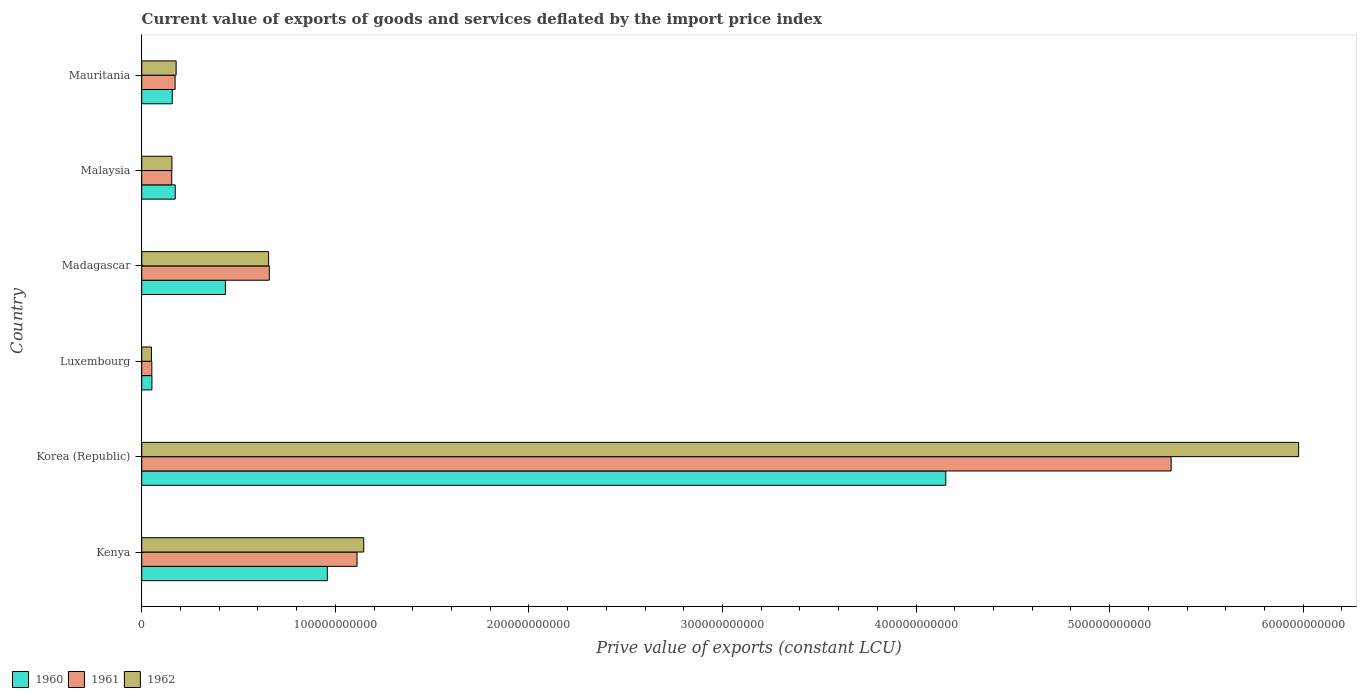How many groups of bars are there?
Offer a very short reply. 6. What is the label of the 6th group of bars from the top?
Offer a very short reply. Kenya. What is the prive value of exports in 1961 in Korea (Republic)?
Your answer should be compact. 5.32e+11. Across all countries, what is the maximum prive value of exports in 1960?
Offer a terse response. 4.15e+11. Across all countries, what is the minimum prive value of exports in 1960?
Your response must be concise. 5.28e+09. In which country was the prive value of exports in 1962 maximum?
Your response must be concise. Korea (Republic). In which country was the prive value of exports in 1960 minimum?
Keep it short and to the point. Luxembourg. What is the total prive value of exports in 1962 in the graph?
Provide a succinct answer. 8.16e+11. What is the difference between the prive value of exports in 1961 in Korea (Republic) and that in Mauritania?
Provide a succinct answer. 5.15e+11. What is the difference between the prive value of exports in 1962 in Luxembourg and the prive value of exports in 1961 in Madagascar?
Make the answer very short. -6.09e+1. What is the average prive value of exports in 1962 per country?
Ensure brevity in your answer.  1.36e+11. What is the difference between the prive value of exports in 1962 and prive value of exports in 1960 in Malaysia?
Your answer should be very brief. -1.70e+09. What is the ratio of the prive value of exports in 1961 in Kenya to that in Madagascar?
Provide a short and direct response. 1.69. Is the prive value of exports in 1960 in Kenya less than that in Madagascar?
Offer a very short reply. No. What is the difference between the highest and the second highest prive value of exports in 1960?
Provide a succinct answer. 3.19e+11. What is the difference between the highest and the lowest prive value of exports in 1962?
Ensure brevity in your answer.  5.93e+11. In how many countries, is the prive value of exports in 1962 greater than the average prive value of exports in 1962 taken over all countries?
Your answer should be very brief. 1. Is the sum of the prive value of exports in 1960 in Kenya and Korea (Republic) greater than the maximum prive value of exports in 1962 across all countries?
Make the answer very short. No. What does the 1st bar from the bottom in Mauritania represents?
Provide a succinct answer. 1960. Are all the bars in the graph horizontal?
Provide a succinct answer. Yes. What is the difference between two consecutive major ticks on the X-axis?
Your answer should be very brief. 1.00e+11. Are the values on the major ticks of X-axis written in scientific E-notation?
Offer a terse response. No. Does the graph contain any zero values?
Keep it short and to the point. No. How are the legend labels stacked?
Make the answer very short. Horizontal. What is the title of the graph?
Your response must be concise. Current value of exports of goods and services deflated by the import price index. Does "1995" appear as one of the legend labels in the graph?
Keep it short and to the point. No. What is the label or title of the X-axis?
Your answer should be very brief. Prive value of exports (constant LCU). What is the label or title of the Y-axis?
Provide a short and direct response. Country. What is the Prive value of exports (constant LCU) of 1960 in Kenya?
Your answer should be very brief. 9.59e+1. What is the Prive value of exports (constant LCU) of 1961 in Kenya?
Provide a succinct answer. 1.11e+11. What is the Prive value of exports (constant LCU) of 1962 in Kenya?
Offer a very short reply. 1.15e+11. What is the Prive value of exports (constant LCU) in 1960 in Korea (Republic)?
Offer a very short reply. 4.15e+11. What is the Prive value of exports (constant LCU) of 1961 in Korea (Republic)?
Your response must be concise. 5.32e+11. What is the Prive value of exports (constant LCU) of 1962 in Korea (Republic)?
Give a very brief answer. 5.98e+11. What is the Prive value of exports (constant LCU) of 1960 in Luxembourg?
Your answer should be very brief. 5.28e+09. What is the Prive value of exports (constant LCU) of 1961 in Luxembourg?
Your response must be concise. 5.22e+09. What is the Prive value of exports (constant LCU) in 1962 in Luxembourg?
Your response must be concise. 5.02e+09. What is the Prive value of exports (constant LCU) of 1960 in Madagascar?
Keep it short and to the point. 4.32e+1. What is the Prive value of exports (constant LCU) of 1961 in Madagascar?
Give a very brief answer. 6.59e+1. What is the Prive value of exports (constant LCU) of 1962 in Madagascar?
Offer a very short reply. 6.55e+1. What is the Prive value of exports (constant LCU) of 1960 in Malaysia?
Ensure brevity in your answer.  1.73e+1. What is the Prive value of exports (constant LCU) in 1961 in Malaysia?
Your answer should be very brief. 1.55e+1. What is the Prive value of exports (constant LCU) in 1962 in Malaysia?
Make the answer very short. 1.56e+1. What is the Prive value of exports (constant LCU) of 1960 in Mauritania?
Make the answer very short. 1.58e+1. What is the Prive value of exports (constant LCU) of 1961 in Mauritania?
Offer a very short reply. 1.72e+1. What is the Prive value of exports (constant LCU) in 1962 in Mauritania?
Give a very brief answer. 1.78e+1. Across all countries, what is the maximum Prive value of exports (constant LCU) of 1960?
Your response must be concise. 4.15e+11. Across all countries, what is the maximum Prive value of exports (constant LCU) of 1961?
Your response must be concise. 5.32e+11. Across all countries, what is the maximum Prive value of exports (constant LCU) in 1962?
Your answer should be compact. 5.98e+11. Across all countries, what is the minimum Prive value of exports (constant LCU) of 1960?
Give a very brief answer. 5.28e+09. Across all countries, what is the minimum Prive value of exports (constant LCU) of 1961?
Provide a short and direct response. 5.22e+09. Across all countries, what is the minimum Prive value of exports (constant LCU) of 1962?
Ensure brevity in your answer.  5.02e+09. What is the total Prive value of exports (constant LCU) of 1960 in the graph?
Offer a terse response. 5.93e+11. What is the total Prive value of exports (constant LCU) in 1961 in the graph?
Make the answer very short. 7.47e+11. What is the total Prive value of exports (constant LCU) of 1962 in the graph?
Your answer should be very brief. 8.16e+11. What is the difference between the Prive value of exports (constant LCU) in 1960 in Kenya and that in Korea (Republic)?
Give a very brief answer. -3.19e+11. What is the difference between the Prive value of exports (constant LCU) in 1961 in Kenya and that in Korea (Republic)?
Provide a succinct answer. -4.21e+11. What is the difference between the Prive value of exports (constant LCU) in 1962 in Kenya and that in Korea (Republic)?
Provide a succinct answer. -4.83e+11. What is the difference between the Prive value of exports (constant LCU) in 1960 in Kenya and that in Luxembourg?
Make the answer very short. 9.06e+1. What is the difference between the Prive value of exports (constant LCU) of 1961 in Kenya and that in Luxembourg?
Offer a terse response. 1.06e+11. What is the difference between the Prive value of exports (constant LCU) in 1962 in Kenya and that in Luxembourg?
Your answer should be very brief. 1.10e+11. What is the difference between the Prive value of exports (constant LCU) of 1960 in Kenya and that in Madagascar?
Provide a short and direct response. 5.27e+1. What is the difference between the Prive value of exports (constant LCU) in 1961 in Kenya and that in Madagascar?
Give a very brief answer. 4.53e+1. What is the difference between the Prive value of exports (constant LCU) of 1962 in Kenya and that in Madagascar?
Make the answer very short. 4.92e+1. What is the difference between the Prive value of exports (constant LCU) of 1960 in Kenya and that in Malaysia?
Offer a very short reply. 7.86e+1. What is the difference between the Prive value of exports (constant LCU) in 1961 in Kenya and that in Malaysia?
Your answer should be very brief. 9.57e+1. What is the difference between the Prive value of exports (constant LCU) in 1962 in Kenya and that in Malaysia?
Ensure brevity in your answer.  9.91e+1. What is the difference between the Prive value of exports (constant LCU) in 1960 in Kenya and that in Mauritania?
Keep it short and to the point. 8.01e+1. What is the difference between the Prive value of exports (constant LCU) in 1961 in Kenya and that in Mauritania?
Your answer should be very brief. 9.40e+1. What is the difference between the Prive value of exports (constant LCU) in 1962 in Kenya and that in Mauritania?
Give a very brief answer. 9.69e+1. What is the difference between the Prive value of exports (constant LCU) of 1960 in Korea (Republic) and that in Luxembourg?
Offer a terse response. 4.10e+11. What is the difference between the Prive value of exports (constant LCU) of 1961 in Korea (Republic) and that in Luxembourg?
Your response must be concise. 5.27e+11. What is the difference between the Prive value of exports (constant LCU) in 1962 in Korea (Republic) and that in Luxembourg?
Keep it short and to the point. 5.93e+11. What is the difference between the Prive value of exports (constant LCU) of 1960 in Korea (Republic) and that in Madagascar?
Provide a short and direct response. 3.72e+11. What is the difference between the Prive value of exports (constant LCU) in 1961 in Korea (Republic) and that in Madagascar?
Your answer should be very brief. 4.66e+11. What is the difference between the Prive value of exports (constant LCU) in 1962 in Korea (Republic) and that in Madagascar?
Your answer should be compact. 5.32e+11. What is the difference between the Prive value of exports (constant LCU) of 1960 in Korea (Republic) and that in Malaysia?
Your answer should be very brief. 3.98e+11. What is the difference between the Prive value of exports (constant LCU) of 1961 in Korea (Republic) and that in Malaysia?
Your response must be concise. 5.16e+11. What is the difference between the Prive value of exports (constant LCU) of 1962 in Korea (Republic) and that in Malaysia?
Your response must be concise. 5.82e+11. What is the difference between the Prive value of exports (constant LCU) in 1960 in Korea (Republic) and that in Mauritania?
Ensure brevity in your answer.  4.00e+11. What is the difference between the Prive value of exports (constant LCU) of 1961 in Korea (Republic) and that in Mauritania?
Keep it short and to the point. 5.15e+11. What is the difference between the Prive value of exports (constant LCU) in 1962 in Korea (Republic) and that in Mauritania?
Offer a terse response. 5.80e+11. What is the difference between the Prive value of exports (constant LCU) in 1960 in Luxembourg and that in Madagascar?
Your answer should be compact. -3.79e+1. What is the difference between the Prive value of exports (constant LCU) of 1961 in Luxembourg and that in Madagascar?
Provide a short and direct response. -6.07e+1. What is the difference between the Prive value of exports (constant LCU) of 1962 in Luxembourg and that in Madagascar?
Ensure brevity in your answer.  -6.05e+1. What is the difference between the Prive value of exports (constant LCU) in 1960 in Luxembourg and that in Malaysia?
Provide a succinct answer. -1.20e+1. What is the difference between the Prive value of exports (constant LCU) in 1961 in Luxembourg and that in Malaysia?
Offer a very short reply. -1.03e+1. What is the difference between the Prive value of exports (constant LCU) of 1962 in Luxembourg and that in Malaysia?
Ensure brevity in your answer.  -1.06e+1. What is the difference between the Prive value of exports (constant LCU) in 1960 in Luxembourg and that in Mauritania?
Your answer should be very brief. -1.05e+1. What is the difference between the Prive value of exports (constant LCU) of 1961 in Luxembourg and that in Mauritania?
Your answer should be compact. -1.20e+1. What is the difference between the Prive value of exports (constant LCU) of 1962 in Luxembourg and that in Mauritania?
Keep it short and to the point. -1.28e+1. What is the difference between the Prive value of exports (constant LCU) in 1960 in Madagascar and that in Malaysia?
Provide a short and direct response. 2.59e+1. What is the difference between the Prive value of exports (constant LCU) in 1961 in Madagascar and that in Malaysia?
Provide a short and direct response. 5.04e+1. What is the difference between the Prive value of exports (constant LCU) in 1962 in Madagascar and that in Malaysia?
Your response must be concise. 4.99e+1. What is the difference between the Prive value of exports (constant LCU) of 1960 in Madagascar and that in Mauritania?
Make the answer very short. 2.74e+1. What is the difference between the Prive value of exports (constant LCU) of 1961 in Madagascar and that in Mauritania?
Offer a terse response. 4.87e+1. What is the difference between the Prive value of exports (constant LCU) of 1962 in Madagascar and that in Mauritania?
Make the answer very short. 4.78e+1. What is the difference between the Prive value of exports (constant LCU) of 1960 in Malaysia and that in Mauritania?
Keep it short and to the point. 1.54e+09. What is the difference between the Prive value of exports (constant LCU) in 1961 in Malaysia and that in Mauritania?
Your answer should be compact. -1.73e+09. What is the difference between the Prive value of exports (constant LCU) in 1962 in Malaysia and that in Mauritania?
Your answer should be compact. -2.17e+09. What is the difference between the Prive value of exports (constant LCU) of 1960 in Kenya and the Prive value of exports (constant LCU) of 1961 in Korea (Republic)?
Give a very brief answer. -4.36e+11. What is the difference between the Prive value of exports (constant LCU) of 1960 in Kenya and the Prive value of exports (constant LCU) of 1962 in Korea (Republic)?
Offer a terse response. -5.02e+11. What is the difference between the Prive value of exports (constant LCU) in 1961 in Kenya and the Prive value of exports (constant LCU) in 1962 in Korea (Republic)?
Your response must be concise. -4.86e+11. What is the difference between the Prive value of exports (constant LCU) in 1960 in Kenya and the Prive value of exports (constant LCU) in 1961 in Luxembourg?
Make the answer very short. 9.07e+1. What is the difference between the Prive value of exports (constant LCU) in 1960 in Kenya and the Prive value of exports (constant LCU) in 1962 in Luxembourg?
Your answer should be compact. 9.09e+1. What is the difference between the Prive value of exports (constant LCU) of 1961 in Kenya and the Prive value of exports (constant LCU) of 1962 in Luxembourg?
Offer a terse response. 1.06e+11. What is the difference between the Prive value of exports (constant LCU) of 1960 in Kenya and the Prive value of exports (constant LCU) of 1961 in Madagascar?
Your answer should be very brief. 3.00e+1. What is the difference between the Prive value of exports (constant LCU) of 1960 in Kenya and the Prive value of exports (constant LCU) of 1962 in Madagascar?
Your answer should be very brief. 3.03e+1. What is the difference between the Prive value of exports (constant LCU) in 1961 in Kenya and the Prive value of exports (constant LCU) in 1962 in Madagascar?
Ensure brevity in your answer.  4.57e+1. What is the difference between the Prive value of exports (constant LCU) of 1960 in Kenya and the Prive value of exports (constant LCU) of 1961 in Malaysia?
Provide a succinct answer. 8.04e+1. What is the difference between the Prive value of exports (constant LCU) in 1960 in Kenya and the Prive value of exports (constant LCU) in 1962 in Malaysia?
Give a very brief answer. 8.03e+1. What is the difference between the Prive value of exports (constant LCU) of 1961 in Kenya and the Prive value of exports (constant LCU) of 1962 in Malaysia?
Provide a short and direct response. 9.56e+1. What is the difference between the Prive value of exports (constant LCU) of 1960 in Kenya and the Prive value of exports (constant LCU) of 1961 in Mauritania?
Provide a succinct answer. 7.86e+1. What is the difference between the Prive value of exports (constant LCU) in 1960 in Kenya and the Prive value of exports (constant LCU) in 1962 in Mauritania?
Ensure brevity in your answer.  7.81e+1. What is the difference between the Prive value of exports (constant LCU) in 1961 in Kenya and the Prive value of exports (constant LCU) in 1962 in Mauritania?
Ensure brevity in your answer.  9.35e+1. What is the difference between the Prive value of exports (constant LCU) of 1960 in Korea (Republic) and the Prive value of exports (constant LCU) of 1961 in Luxembourg?
Offer a terse response. 4.10e+11. What is the difference between the Prive value of exports (constant LCU) of 1960 in Korea (Republic) and the Prive value of exports (constant LCU) of 1962 in Luxembourg?
Provide a short and direct response. 4.10e+11. What is the difference between the Prive value of exports (constant LCU) of 1961 in Korea (Republic) and the Prive value of exports (constant LCU) of 1962 in Luxembourg?
Your answer should be compact. 5.27e+11. What is the difference between the Prive value of exports (constant LCU) in 1960 in Korea (Republic) and the Prive value of exports (constant LCU) in 1961 in Madagascar?
Make the answer very short. 3.49e+11. What is the difference between the Prive value of exports (constant LCU) of 1960 in Korea (Republic) and the Prive value of exports (constant LCU) of 1962 in Madagascar?
Offer a very short reply. 3.50e+11. What is the difference between the Prive value of exports (constant LCU) in 1961 in Korea (Republic) and the Prive value of exports (constant LCU) in 1962 in Madagascar?
Give a very brief answer. 4.66e+11. What is the difference between the Prive value of exports (constant LCU) of 1960 in Korea (Republic) and the Prive value of exports (constant LCU) of 1961 in Malaysia?
Keep it short and to the point. 4.00e+11. What is the difference between the Prive value of exports (constant LCU) of 1960 in Korea (Republic) and the Prive value of exports (constant LCU) of 1962 in Malaysia?
Provide a short and direct response. 4.00e+11. What is the difference between the Prive value of exports (constant LCU) in 1961 in Korea (Republic) and the Prive value of exports (constant LCU) in 1962 in Malaysia?
Make the answer very short. 5.16e+11. What is the difference between the Prive value of exports (constant LCU) of 1960 in Korea (Republic) and the Prive value of exports (constant LCU) of 1961 in Mauritania?
Your response must be concise. 3.98e+11. What is the difference between the Prive value of exports (constant LCU) of 1960 in Korea (Republic) and the Prive value of exports (constant LCU) of 1962 in Mauritania?
Make the answer very short. 3.98e+11. What is the difference between the Prive value of exports (constant LCU) of 1961 in Korea (Republic) and the Prive value of exports (constant LCU) of 1962 in Mauritania?
Offer a terse response. 5.14e+11. What is the difference between the Prive value of exports (constant LCU) of 1960 in Luxembourg and the Prive value of exports (constant LCU) of 1961 in Madagascar?
Your answer should be very brief. -6.06e+1. What is the difference between the Prive value of exports (constant LCU) in 1960 in Luxembourg and the Prive value of exports (constant LCU) in 1962 in Madagascar?
Make the answer very short. -6.03e+1. What is the difference between the Prive value of exports (constant LCU) in 1961 in Luxembourg and the Prive value of exports (constant LCU) in 1962 in Madagascar?
Make the answer very short. -6.03e+1. What is the difference between the Prive value of exports (constant LCU) of 1960 in Luxembourg and the Prive value of exports (constant LCU) of 1961 in Malaysia?
Offer a very short reply. -1.02e+1. What is the difference between the Prive value of exports (constant LCU) in 1960 in Luxembourg and the Prive value of exports (constant LCU) in 1962 in Malaysia?
Your answer should be compact. -1.03e+1. What is the difference between the Prive value of exports (constant LCU) in 1961 in Luxembourg and the Prive value of exports (constant LCU) in 1962 in Malaysia?
Offer a very short reply. -1.04e+1. What is the difference between the Prive value of exports (constant LCU) of 1960 in Luxembourg and the Prive value of exports (constant LCU) of 1961 in Mauritania?
Your response must be concise. -1.20e+1. What is the difference between the Prive value of exports (constant LCU) of 1960 in Luxembourg and the Prive value of exports (constant LCU) of 1962 in Mauritania?
Make the answer very short. -1.25e+1. What is the difference between the Prive value of exports (constant LCU) in 1961 in Luxembourg and the Prive value of exports (constant LCU) in 1962 in Mauritania?
Make the answer very short. -1.26e+1. What is the difference between the Prive value of exports (constant LCU) in 1960 in Madagascar and the Prive value of exports (constant LCU) in 1961 in Malaysia?
Keep it short and to the point. 2.77e+1. What is the difference between the Prive value of exports (constant LCU) of 1960 in Madagascar and the Prive value of exports (constant LCU) of 1962 in Malaysia?
Offer a terse response. 2.76e+1. What is the difference between the Prive value of exports (constant LCU) in 1961 in Madagascar and the Prive value of exports (constant LCU) in 1962 in Malaysia?
Your response must be concise. 5.03e+1. What is the difference between the Prive value of exports (constant LCU) of 1960 in Madagascar and the Prive value of exports (constant LCU) of 1961 in Mauritania?
Keep it short and to the point. 2.60e+1. What is the difference between the Prive value of exports (constant LCU) of 1960 in Madagascar and the Prive value of exports (constant LCU) of 1962 in Mauritania?
Offer a terse response. 2.54e+1. What is the difference between the Prive value of exports (constant LCU) in 1961 in Madagascar and the Prive value of exports (constant LCU) in 1962 in Mauritania?
Your response must be concise. 4.81e+1. What is the difference between the Prive value of exports (constant LCU) of 1960 in Malaysia and the Prive value of exports (constant LCU) of 1961 in Mauritania?
Keep it short and to the point. 6.80e+07. What is the difference between the Prive value of exports (constant LCU) of 1960 in Malaysia and the Prive value of exports (constant LCU) of 1962 in Mauritania?
Your response must be concise. -4.67e+08. What is the difference between the Prive value of exports (constant LCU) of 1961 in Malaysia and the Prive value of exports (constant LCU) of 1962 in Mauritania?
Your answer should be compact. -2.27e+09. What is the average Prive value of exports (constant LCU) in 1960 per country?
Provide a short and direct response. 9.88e+1. What is the average Prive value of exports (constant LCU) in 1961 per country?
Ensure brevity in your answer.  1.24e+11. What is the average Prive value of exports (constant LCU) of 1962 per country?
Provide a short and direct response. 1.36e+11. What is the difference between the Prive value of exports (constant LCU) in 1960 and Prive value of exports (constant LCU) in 1961 in Kenya?
Make the answer very short. -1.54e+1. What is the difference between the Prive value of exports (constant LCU) in 1960 and Prive value of exports (constant LCU) in 1962 in Kenya?
Ensure brevity in your answer.  -1.88e+1. What is the difference between the Prive value of exports (constant LCU) in 1961 and Prive value of exports (constant LCU) in 1962 in Kenya?
Keep it short and to the point. -3.47e+09. What is the difference between the Prive value of exports (constant LCU) in 1960 and Prive value of exports (constant LCU) in 1961 in Korea (Republic)?
Your answer should be compact. -1.16e+11. What is the difference between the Prive value of exports (constant LCU) of 1960 and Prive value of exports (constant LCU) of 1962 in Korea (Republic)?
Provide a short and direct response. -1.82e+11. What is the difference between the Prive value of exports (constant LCU) in 1961 and Prive value of exports (constant LCU) in 1962 in Korea (Republic)?
Offer a very short reply. -6.59e+1. What is the difference between the Prive value of exports (constant LCU) in 1960 and Prive value of exports (constant LCU) in 1961 in Luxembourg?
Your response must be concise. 5.55e+07. What is the difference between the Prive value of exports (constant LCU) of 1960 and Prive value of exports (constant LCU) of 1962 in Luxembourg?
Your response must be concise. 2.64e+08. What is the difference between the Prive value of exports (constant LCU) in 1961 and Prive value of exports (constant LCU) in 1962 in Luxembourg?
Offer a terse response. 2.08e+08. What is the difference between the Prive value of exports (constant LCU) in 1960 and Prive value of exports (constant LCU) in 1961 in Madagascar?
Offer a very short reply. -2.27e+1. What is the difference between the Prive value of exports (constant LCU) of 1960 and Prive value of exports (constant LCU) of 1962 in Madagascar?
Your answer should be compact. -2.23e+1. What is the difference between the Prive value of exports (constant LCU) in 1961 and Prive value of exports (constant LCU) in 1962 in Madagascar?
Provide a short and direct response. 3.52e+08. What is the difference between the Prive value of exports (constant LCU) in 1960 and Prive value of exports (constant LCU) in 1961 in Malaysia?
Give a very brief answer. 1.80e+09. What is the difference between the Prive value of exports (constant LCU) in 1960 and Prive value of exports (constant LCU) in 1962 in Malaysia?
Give a very brief answer. 1.70e+09. What is the difference between the Prive value of exports (constant LCU) of 1961 and Prive value of exports (constant LCU) of 1962 in Malaysia?
Ensure brevity in your answer.  -1.01e+08. What is the difference between the Prive value of exports (constant LCU) of 1960 and Prive value of exports (constant LCU) of 1961 in Mauritania?
Ensure brevity in your answer.  -1.47e+09. What is the difference between the Prive value of exports (constant LCU) in 1960 and Prive value of exports (constant LCU) in 1962 in Mauritania?
Make the answer very short. -2.01e+09. What is the difference between the Prive value of exports (constant LCU) of 1961 and Prive value of exports (constant LCU) of 1962 in Mauritania?
Offer a terse response. -5.35e+08. What is the ratio of the Prive value of exports (constant LCU) in 1960 in Kenya to that in Korea (Republic)?
Keep it short and to the point. 0.23. What is the ratio of the Prive value of exports (constant LCU) in 1961 in Kenya to that in Korea (Republic)?
Your answer should be very brief. 0.21. What is the ratio of the Prive value of exports (constant LCU) of 1962 in Kenya to that in Korea (Republic)?
Keep it short and to the point. 0.19. What is the ratio of the Prive value of exports (constant LCU) of 1960 in Kenya to that in Luxembourg?
Make the answer very short. 18.16. What is the ratio of the Prive value of exports (constant LCU) in 1961 in Kenya to that in Luxembourg?
Provide a succinct answer. 21.29. What is the ratio of the Prive value of exports (constant LCU) of 1962 in Kenya to that in Luxembourg?
Make the answer very short. 22.87. What is the ratio of the Prive value of exports (constant LCU) in 1960 in Kenya to that in Madagascar?
Keep it short and to the point. 2.22. What is the ratio of the Prive value of exports (constant LCU) in 1961 in Kenya to that in Madagascar?
Offer a very short reply. 1.69. What is the ratio of the Prive value of exports (constant LCU) of 1960 in Kenya to that in Malaysia?
Your response must be concise. 5.54. What is the ratio of the Prive value of exports (constant LCU) of 1961 in Kenya to that in Malaysia?
Give a very brief answer. 7.17. What is the ratio of the Prive value of exports (constant LCU) in 1962 in Kenya to that in Malaysia?
Provide a short and direct response. 7.35. What is the ratio of the Prive value of exports (constant LCU) of 1960 in Kenya to that in Mauritania?
Your answer should be compact. 6.08. What is the ratio of the Prive value of exports (constant LCU) of 1961 in Kenya to that in Mauritania?
Offer a terse response. 6.45. What is the ratio of the Prive value of exports (constant LCU) in 1962 in Kenya to that in Mauritania?
Your response must be concise. 6.45. What is the ratio of the Prive value of exports (constant LCU) in 1960 in Korea (Republic) to that in Luxembourg?
Give a very brief answer. 78.67. What is the ratio of the Prive value of exports (constant LCU) in 1961 in Korea (Republic) to that in Luxembourg?
Offer a very short reply. 101.79. What is the ratio of the Prive value of exports (constant LCU) in 1962 in Korea (Republic) to that in Luxembourg?
Ensure brevity in your answer.  119.15. What is the ratio of the Prive value of exports (constant LCU) in 1960 in Korea (Republic) to that in Madagascar?
Your answer should be very brief. 9.61. What is the ratio of the Prive value of exports (constant LCU) in 1961 in Korea (Republic) to that in Madagascar?
Give a very brief answer. 8.07. What is the ratio of the Prive value of exports (constant LCU) of 1962 in Korea (Republic) to that in Madagascar?
Your answer should be compact. 9.12. What is the ratio of the Prive value of exports (constant LCU) in 1960 in Korea (Republic) to that in Malaysia?
Give a very brief answer. 23.99. What is the ratio of the Prive value of exports (constant LCU) of 1961 in Korea (Republic) to that in Malaysia?
Make the answer very short. 34.28. What is the ratio of the Prive value of exports (constant LCU) in 1962 in Korea (Republic) to that in Malaysia?
Offer a terse response. 38.28. What is the ratio of the Prive value of exports (constant LCU) in 1960 in Korea (Republic) to that in Mauritania?
Keep it short and to the point. 26.33. What is the ratio of the Prive value of exports (constant LCU) of 1961 in Korea (Republic) to that in Mauritania?
Keep it short and to the point. 30.84. What is the ratio of the Prive value of exports (constant LCU) in 1962 in Korea (Republic) to that in Mauritania?
Offer a very short reply. 33.61. What is the ratio of the Prive value of exports (constant LCU) of 1960 in Luxembourg to that in Madagascar?
Keep it short and to the point. 0.12. What is the ratio of the Prive value of exports (constant LCU) in 1961 in Luxembourg to that in Madagascar?
Offer a terse response. 0.08. What is the ratio of the Prive value of exports (constant LCU) of 1962 in Luxembourg to that in Madagascar?
Keep it short and to the point. 0.08. What is the ratio of the Prive value of exports (constant LCU) in 1960 in Luxembourg to that in Malaysia?
Provide a succinct answer. 0.3. What is the ratio of the Prive value of exports (constant LCU) in 1961 in Luxembourg to that in Malaysia?
Your response must be concise. 0.34. What is the ratio of the Prive value of exports (constant LCU) in 1962 in Luxembourg to that in Malaysia?
Your answer should be compact. 0.32. What is the ratio of the Prive value of exports (constant LCU) in 1960 in Luxembourg to that in Mauritania?
Your response must be concise. 0.33. What is the ratio of the Prive value of exports (constant LCU) of 1961 in Luxembourg to that in Mauritania?
Provide a succinct answer. 0.3. What is the ratio of the Prive value of exports (constant LCU) of 1962 in Luxembourg to that in Mauritania?
Offer a terse response. 0.28. What is the ratio of the Prive value of exports (constant LCU) of 1960 in Madagascar to that in Malaysia?
Offer a terse response. 2.5. What is the ratio of the Prive value of exports (constant LCU) of 1961 in Madagascar to that in Malaysia?
Your response must be concise. 4.25. What is the ratio of the Prive value of exports (constant LCU) of 1962 in Madagascar to that in Malaysia?
Provide a short and direct response. 4.2. What is the ratio of the Prive value of exports (constant LCU) in 1960 in Madagascar to that in Mauritania?
Keep it short and to the point. 2.74. What is the ratio of the Prive value of exports (constant LCU) of 1961 in Madagascar to that in Mauritania?
Ensure brevity in your answer.  3.82. What is the ratio of the Prive value of exports (constant LCU) of 1962 in Madagascar to that in Mauritania?
Offer a very short reply. 3.69. What is the ratio of the Prive value of exports (constant LCU) of 1960 in Malaysia to that in Mauritania?
Offer a terse response. 1.1. What is the ratio of the Prive value of exports (constant LCU) in 1961 in Malaysia to that in Mauritania?
Offer a terse response. 0.9. What is the ratio of the Prive value of exports (constant LCU) of 1962 in Malaysia to that in Mauritania?
Keep it short and to the point. 0.88. What is the difference between the highest and the second highest Prive value of exports (constant LCU) of 1960?
Your answer should be compact. 3.19e+11. What is the difference between the highest and the second highest Prive value of exports (constant LCU) in 1961?
Provide a succinct answer. 4.21e+11. What is the difference between the highest and the second highest Prive value of exports (constant LCU) of 1962?
Your response must be concise. 4.83e+11. What is the difference between the highest and the lowest Prive value of exports (constant LCU) of 1960?
Your response must be concise. 4.10e+11. What is the difference between the highest and the lowest Prive value of exports (constant LCU) in 1961?
Your answer should be very brief. 5.27e+11. What is the difference between the highest and the lowest Prive value of exports (constant LCU) of 1962?
Provide a succinct answer. 5.93e+11. 